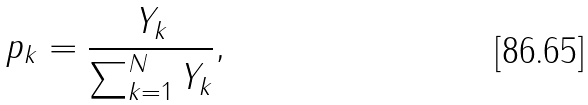Convert formula to latex. <formula><loc_0><loc_0><loc_500><loc_500>p _ { k } = \frac { Y _ { k } } { \sum _ { k = 1 } ^ { N } { Y _ { k } } } ,</formula> 